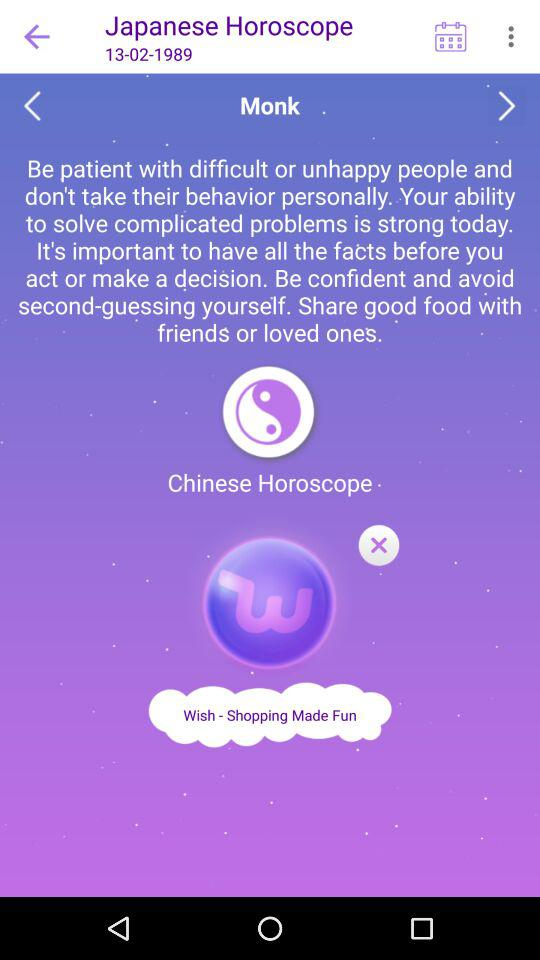What is the selected date? The date is February 13, 1989. 